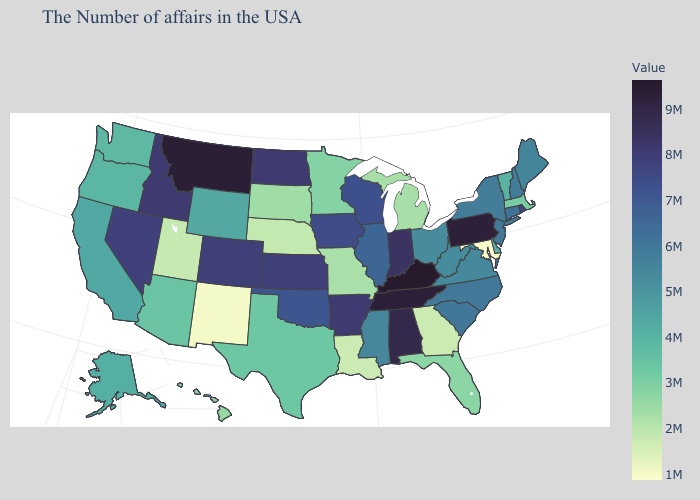Which states have the highest value in the USA?
Answer briefly. Kentucky. Does South Dakota have the lowest value in the MidWest?
Concise answer only. No. Does Oregon have the highest value in the West?
Concise answer only. No. Which states have the lowest value in the West?
Answer briefly. New Mexico. Among the states that border New Mexico , does Texas have the highest value?
Be succinct. No. Does South Carolina have a higher value than Kentucky?
Concise answer only. No. 